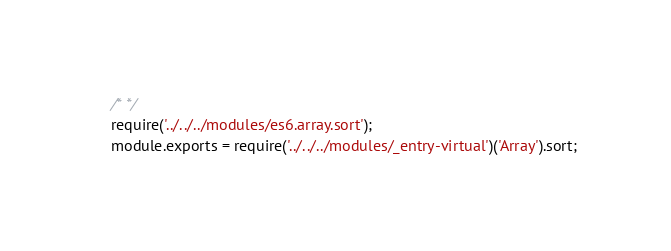Convert code to text. <code><loc_0><loc_0><loc_500><loc_500><_JavaScript_>/* */ 
require('../../../modules/es6.array.sort');
module.exports = require('../../../modules/_entry-virtual')('Array').sort;
</code> 